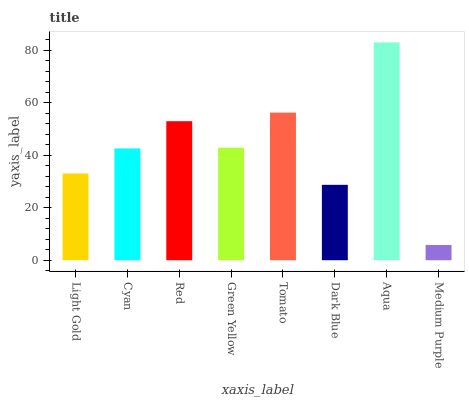Is Medium Purple the minimum?
Answer yes or no. Yes. Is Aqua the maximum?
Answer yes or no. Yes. Is Cyan the minimum?
Answer yes or no. No. Is Cyan the maximum?
Answer yes or no. No. Is Cyan greater than Light Gold?
Answer yes or no. Yes. Is Light Gold less than Cyan?
Answer yes or no. Yes. Is Light Gold greater than Cyan?
Answer yes or no. No. Is Cyan less than Light Gold?
Answer yes or no. No. Is Green Yellow the high median?
Answer yes or no. Yes. Is Cyan the low median?
Answer yes or no. Yes. Is Light Gold the high median?
Answer yes or no. No. Is Dark Blue the low median?
Answer yes or no. No. 